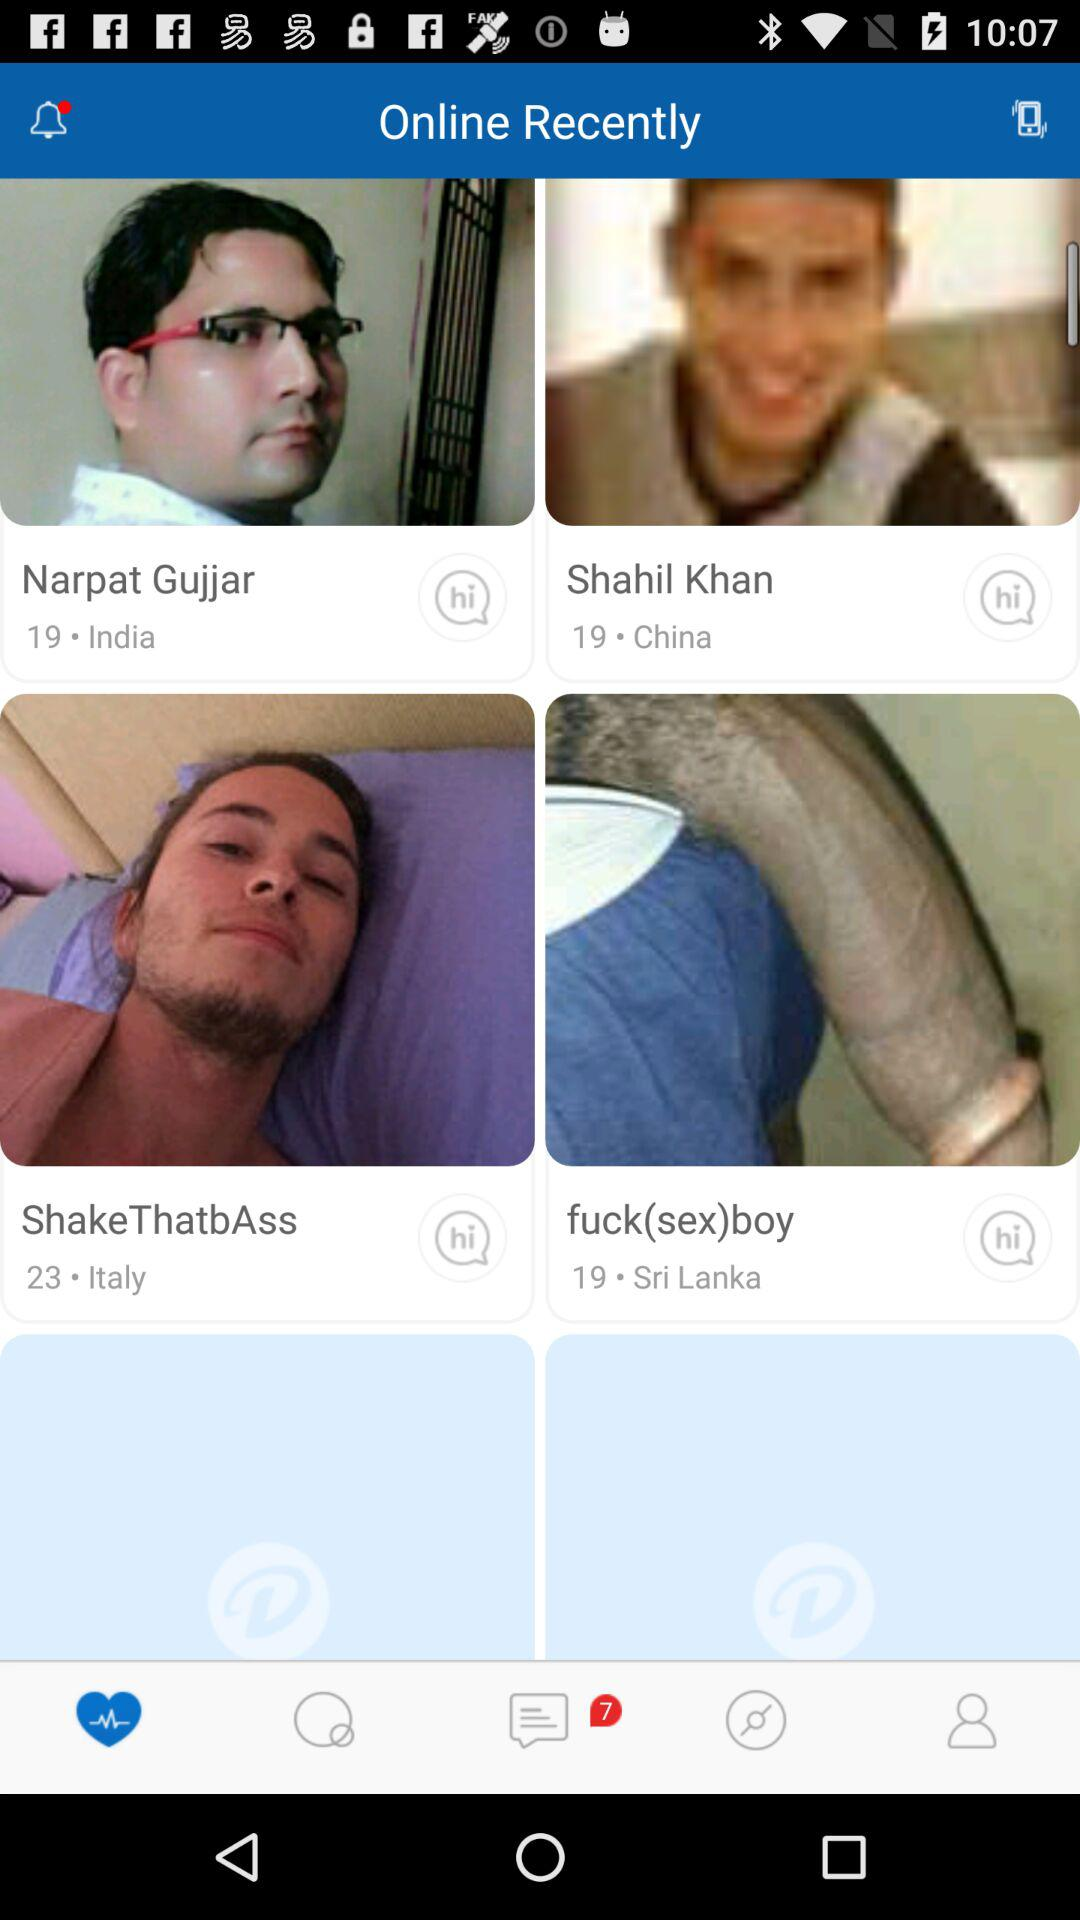What application will receive the public profile and friend list? The application that will receive the public profile and friend list is "Dating". 